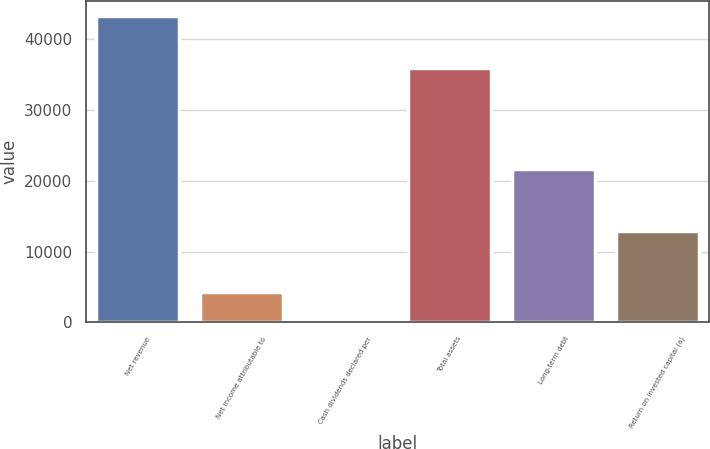Convert chart to OTSL. <chart><loc_0><loc_0><loc_500><loc_500><bar_chart><fcel>Net revenue<fcel>Net income attributable to<fcel>Cash dividends declared per<fcel>Total assets<fcel>Long-term debt<fcel>Return on invested capital (a)<nl><fcel>43251<fcel>4326.59<fcel>1.65<fcel>35994<fcel>21626.3<fcel>12976.5<nl></chart> 